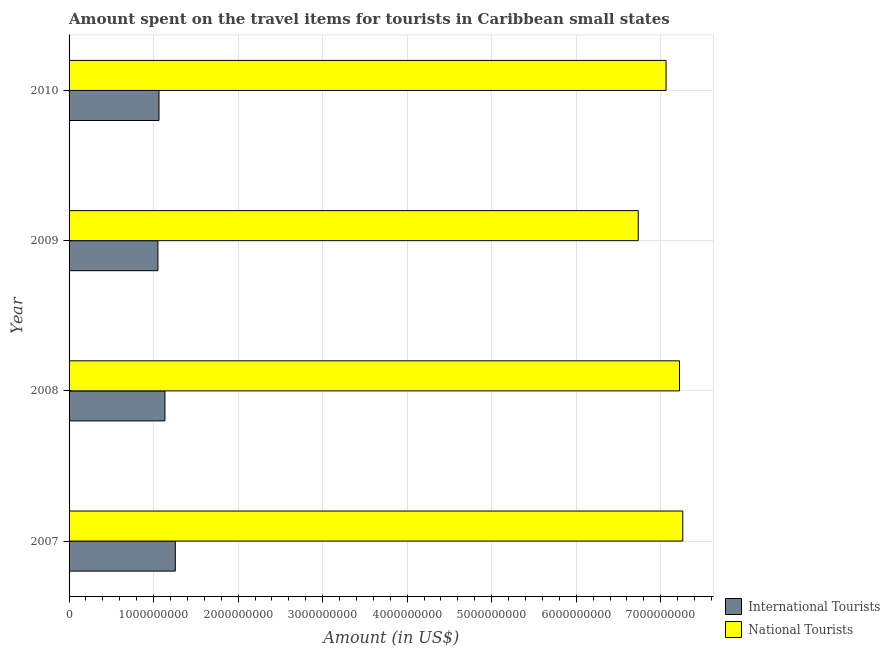How many groups of bars are there?
Provide a succinct answer. 4. Are the number of bars on each tick of the Y-axis equal?
Give a very brief answer. Yes. How many bars are there on the 4th tick from the bottom?
Offer a terse response. 2. What is the label of the 3rd group of bars from the top?
Keep it short and to the point. 2008. In how many cases, is the number of bars for a given year not equal to the number of legend labels?
Provide a short and direct response. 0. What is the amount spent on travel items of national tourists in 2008?
Give a very brief answer. 7.22e+09. Across all years, what is the maximum amount spent on travel items of national tourists?
Keep it short and to the point. 7.26e+09. Across all years, what is the minimum amount spent on travel items of international tourists?
Your answer should be compact. 1.05e+09. In which year was the amount spent on travel items of national tourists maximum?
Your answer should be very brief. 2007. What is the total amount spent on travel items of international tourists in the graph?
Provide a short and direct response. 4.51e+09. What is the difference between the amount spent on travel items of international tourists in 2007 and that in 2009?
Ensure brevity in your answer.  2.06e+08. What is the difference between the amount spent on travel items of national tourists in 2009 and the amount spent on travel items of international tourists in 2010?
Offer a very short reply. 5.67e+09. What is the average amount spent on travel items of international tourists per year?
Make the answer very short. 1.13e+09. In the year 2010, what is the difference between the amount spent on travel items of national tourists and amount spent on travel items of international tourists?
Give a very brief answer. 6.00e+09. What is the ratio of the amount spent on travel items of international tourists in 2008 to that in 2010?
Your answer should be very brief. 1.07. Is the amount spent on travel items of international tourists in 2009 less than that in 2010?
Provide a succinct answer. Yes. Is the difference between the amount spent on travel items of national tourists in 2007 and 2009 greater than the difference between the amount spent on travel items of international tourists in 2007 and 2009?
Ensure brevity in your answer.  Yes. What is the difference between the highest and the second highest amount spent on travel items of international tourists?
Your answer should be compact. 1.23e+08. What is the difference between the highest and the lowest amount spent on travel items of national tourists?
Your response must be concise. 5.27e+08. In how many years, is the amount spent on travel items of national tourists greater than the average amount spent on travel items of national tourists taken over all years?
Provide a succinct answer. 2. Is the sum of the amount spent on travel items of international tourists in 2007 and 2008 greater than the maximum amount spent on travel items of national tourists across all years?
Your answer should be compact. No. What does the 1st bar from the top in 2009 represents?
Keep it short and to the point. National Tourists. What does the 1st bar from the bottom in 2007 represents?
Provide a short and direct response. International Tourists. How many bars are there?
Your answer should be compact. 8. Are all the bars in the graph horizontal?
Your response must be concise. Yes. What is the difference between two consecutive major ticks on the X-axis?
Keep it short and to the point. 1.00e+09. Are the values on the major ticks of X-axis written in scientific E-notation?
Give a very brief answer. No. Does the graph contain any zero values?
Give a very brief answer. No. How are the legend labels stacked?
Your response must be concise. Vertical. What is the title of the graph?
Offer a terse response. Amount spent on the travel items for tourists in Caribbean small states. Does "Constant 2005 US$" appear as one of the legend labels in the graph?
Your answer should be compact. No. What is the label or title of the Y-axis?
Your response must be concise. Year. What is the Amount (in US$) of International Tourists in 2007?
Your answer should be very brief. 1.26e+09. What is the Amount (in US$) in National Tourists in 2007?
Make the answer very short. 7.26e+09. What is the Amount (in US$) of International Tourists in 2008?
Provide a short and direct response. 1.13e+09. What is the Amount (in US$) in National Tourists in 2008?
Your answer should be compact. 7.22e+09. What is the Amount (in US$) in International Tourists in 2009?
Offer a very short reply. 1.05e+09. What is the Amount (in US$) of National Tourists in 2009?
Your answer should be very brief. 6.73e+09. What is the Amount (in US$) in International Tourists in 2010?
Make the answer very short. 1.06e+09. What is the Amount (in US$) in National Tourists in 2010?
Your answer should be very brief. 7.06e+09. Across all years, what is the maximum Amount (in US$) in International Tourists?
Offer a terse response. 1.26e+09. Across all years, what is the maximum Amount (in US$) in National Tourists?
Offer a terse response. 7.26e+09. Across all years, what is the minimum Amount (in US$) in International Tourists?
Provide a short and direct response. 1.05e+09. Across all years, what is the minimum Amount (in US$) in National Tourists?
Give a very brief answer. 6.73e+09. What is the total Amount (in US$) in International Tourists in the graph?
Your answer should be compact. 4.51e+09. What is the total Amount (in US$) in National Tourists in the graph?
Your answer should be compact. 2.83e+1. What is the difference between the Amount (in US$) of International Tourists in 2007 and that in 2008?
Your answer should be very brief. 1.23e+08. What is the difference between the Amount (in US$) of National Tourists in 2007 and that in 2008?
Provide a succinct answer. 3.90e+07. What is the difference between the Amount (in US$) of International Tourists in 2007 and that in 2009?
Give a very brief answer. 2.06e+08. What is the difference between the Amount (in US$) of National Tourists in 2007 and that in 2009?
Offer a very short reply. 5.27e+08. What is the difference between the Amount (in US$) of International Tourists in 2007 and that in 2010?
Make the answer very short. 1.93e+08. What is the difference between the Amount (in US$) of National Tourists in 2007 and that in 2010?
Offer a terse response. 1.98e+08. What is the difference between the Amount (in US$) of International Tourists in 2008 and that in 2009?
Provide a short and direct response. 8.30e+07. What is the difference between the Amount (in US$) in National Tourists in 2008 and that in 2009?
Offer a terse response. 4.88e+08. What is the difference between the Amount (in US$) of International Tourists in 2008 and that in 2010?
Ensure brevity in your answer.  7.00e+07. What is the difference between the Amount (in US$) of National Tourists in 2008 and that in 2010?
Offer a terse response. 1.59e+08. What is the difference between the Amount (in US$) in International Tourists in 2009 and that in 2010?
Make the answer very short. -1.30e+07. What is the difference between the Amount (in US$) in National Tourists in 2009 and that in 2010?
Provide a short and direct response. -3.29e+08. What is the difference between the Amount (in US$) in International Tourists in 2007 and the Amount (in US$) in National Tourists in 2008?
Give a very brief answer. -5.96e+09. What is the difference between the Amount (in US$) of International Tourists in 2007 and the Amount (in US$) of National Tourists in 2009?
Your answer should be compact. -5.48e+09. What is the difference between the Amount (in US$) in International Tourists in 2007 and the Amount (in US$) in National Tourists in 2010?
Make the answer very short. -5.81e+09. What is the difference between the Amount (in US$) in International Tourists in 2008 and the Amount (in US$) in National Tourists in 2009?
Provide a succinct answer. -5.60e+09. What is the difference between the Amount (in US$) in International Tourists in 2008 and the Amount (in US$) in National Tourists in 2010?
Make the answer very short. -5.93e+09. What is the difference between the Amount (in US$) of International Tourists in 2009 and the Amount (in US$) of National Tourists in 2010?
Provide a short and direct response. -6.01e+09. What is the average Amount (in US$) of International Tourists per year?
Give a very brief answer. 1.13e+09. What is the average Amount (in US$) in National Tourists per year?
Your response must be concise. 7.07e+09. In the year 2007, what is the difference between the Amount (in US$) of International Tourists and Amount (in US$) of National Tourists?
Keep it short and to the point. -6.00e+09. In the year 2008, what is the difference between the Amount (in US$) in International Tourists and Amount (in US$) in National Tourists?
Provide a short and direct response. -6.09e+09. In the year 2009, what is the difference between the Amount (in US$) in International Tourists and Amount (in US$) in National Tourists?
Offer a terse response. -5.68e+09. In the year 2010, what is the difference between the Amount (in US$) of International Tourists and Amount (in US$) of National Tourists?
Offer a very short reply. -6.00e+09. What is the ratio of the Amount (in US$) of International Tourists in 2007 to that in 2008?
Your answer should be very brief. 1.11. What is the ratio of the Amount (in US$) of National Tourists in 2007 to that in 2008?
Make the answer very short. 1.01. What is the ratio of the Amount (in US$) in International Tourists in 2007 to that in 2009?
Ensure brevity in your answer.  1.2. What is the ratio of the Amount (in US$) in National Tourists in 2007 to that in 2009?
Give a very brief answer. 1.08. What is the ratio of the Amount (in US$) in International Tourists in 2007 to that in 2010?
Offer a very short reply. 1.18. What is the ratio of the Amount (in US$) of National Tourists in 2007 to that in 2010?
Keep it short and to the point. 1.03. What is the ratio of the Amount (in US$) in International Tourists in 2008 to that in 2009?
Offer a terse response. 1.08. What is the ratio of the Amount (in US$) of National Tourists in 2008 to that in 2009?
Give a very brief answer. 1.07. What is the ratio of the Amount (in US$) in International Tourists in 2008 to that in 2010?
Offer a terse response. 1.07. What is the ratio of the Amount (in US$) in National Tourists in 2008 to that in 2010?
Give a very brief answer. 1.02. What is the ratio of the Amount (in US$) of National Tourists in 2009 to that in 2010?
Give a very brief answer. 0.95. What is the difference between the highest and the second highest Amount (in US$) in International Tourists?
Give a very brief answer. 1.23e+08. What is the difference between the highest and the second highest Amount (in US$) of National Tourists?
Ensure brevity in your answer.  3.90e+07. What is the difference between the highest and the lowest Amount (in US$) of International Tourists?
Provide a succinct answer. 2.06e+08. What is the difference between the highest and the lowest Amount (in US$) of National Tourists?
Provide a succinct answer. 5.27e+08. 